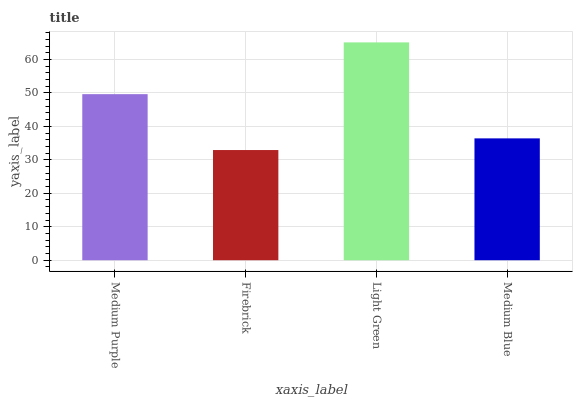Is Firebrick the minimum?
Answer yes or no. Yes. Is Light Green the maximum?
Answer yes or no. Yes. Is Light Green the minimum?
Answer yes or no. No. Is Firebrick the maximum?
Answer yes or no. No. Is Light Green greater than Firebrick?
Answer yes or no. Yes. Is Firebrick less than Light Green?
Answer yes or no. Yes. Is Firebrick greater than Light Green?
Answer yes or no. No. Is Light Green less than Firebrick?
Answer yes or no. No. Is Medium Purple the high median?
Answer yes or no. Yes. Is Medium Blue the low median?
Answer yes or no. Yes. Is Medium Blue the high median?
Answer yes or no. No. Is Medium Purple the low median?
Answer yes or no. No. 